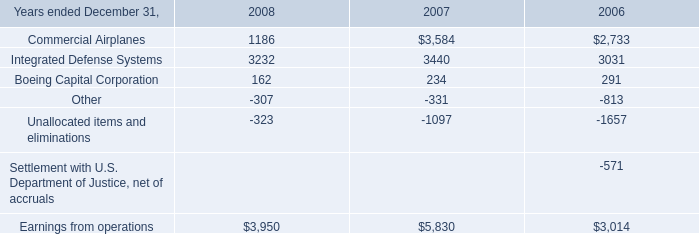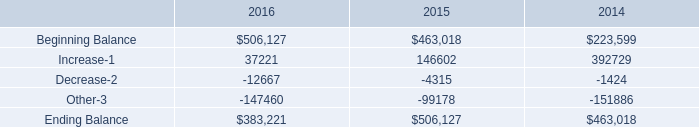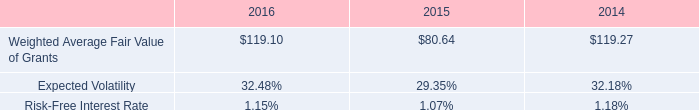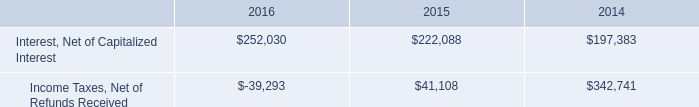considering the years 2015-2016 , what is variation observed in the number of stocks that were excluded , in millions? 
Computations: (5.3 - 4.5)
Answer: 0.8. 